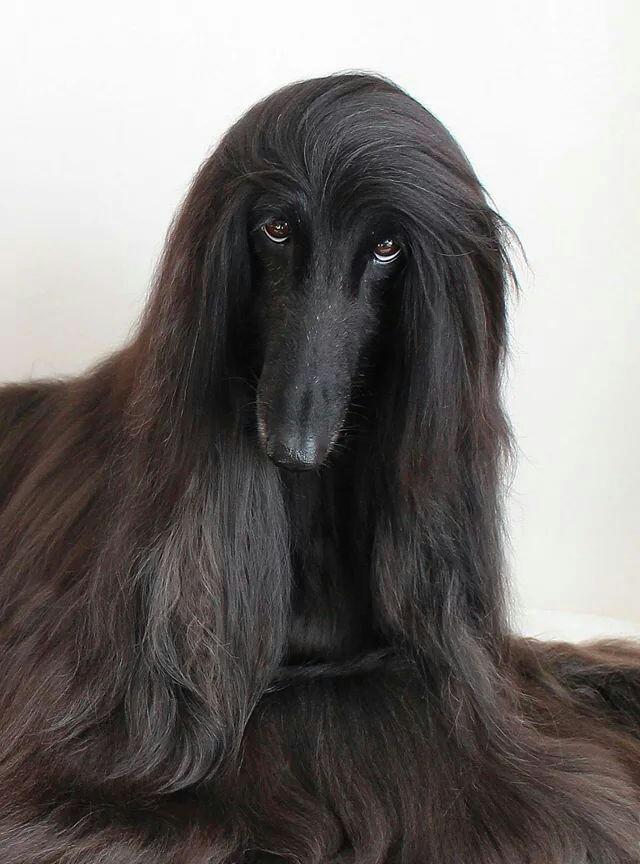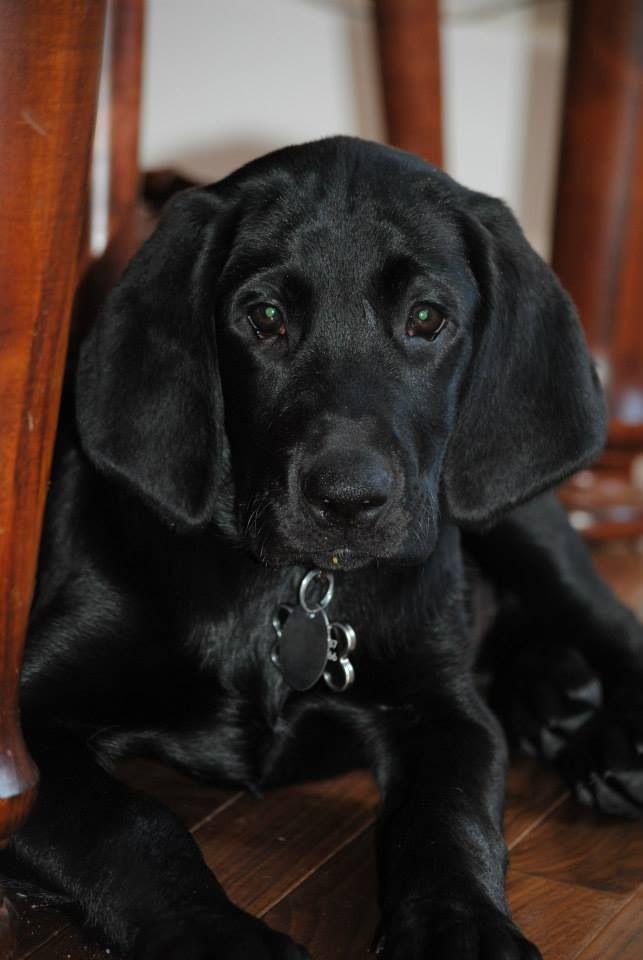The first image is the image on the left, the second image is the image on the right. Given the left and right images, does the statement "One of the images has a black dog with long hair standing up." hold true? Answer yes or no. No. The first image is the image on the left, the second image is the image on the right. Given the left and right images, does the statement "Each image contains a black afghan hound, and the right image shows a hound standing with its body in profile." hold true? Answer yes or no. No. 